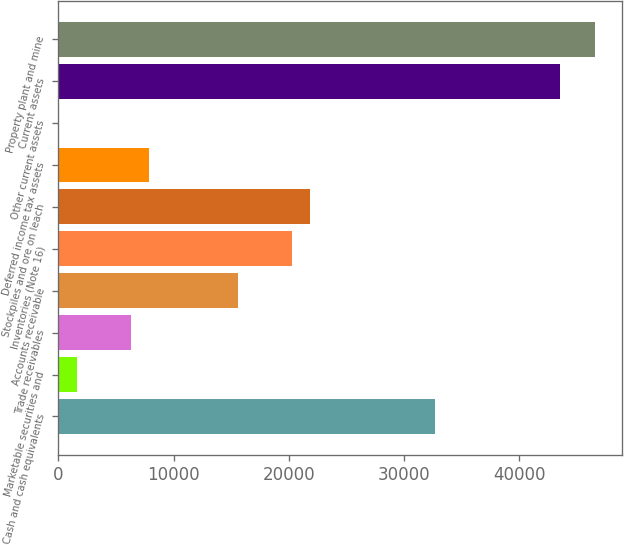<chart> <loc_0><loc_0><loc_500><loc_500><bar_chart><fcel>Cash and cash equivalents<fcel>Marketable securities and<fcel>Trade receivables<fcel>Accounts receivable<fcel>Inventories (Note 16)<fcel>Stockpiles and ore on leach<fcel>Deferred income tax assets<fcel>Other current assets<fcel>Current assets<fcel>Property plant and mine<nl><fcel>32659.8<fcel>1643.8<fcel>6296.2<fcel>15601<fcel>20253.4<fcel>21804.2<fcel>7847<fcel>93<fcel>43515.4<fcel>46617<nl></chart> 